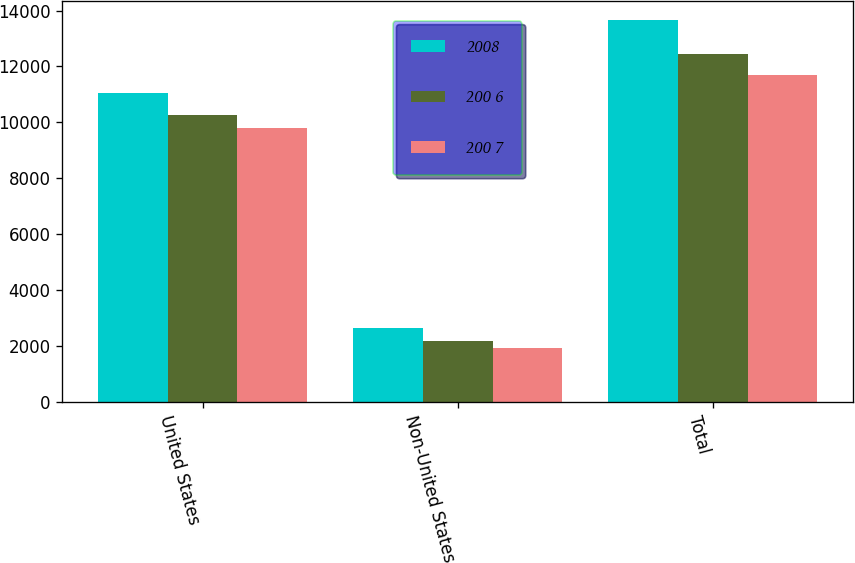Convert chart to OTSL. <chart><loc_0><loc_0><loc_500><loc_500><stacked_bar_chart><ecel><fcel>United States<fcel>Non-United States<fcel>Total<nl><fcel>2008<fcel>11036.7<fcel>2615.4<fcel>13652.1<nl><fcel>200 6<fcel>10258.7<fcel>2182.8<fcel>12441.5<nl><fcel>200 7<fcel>9810.6<fcel>1900.7<fcel>11711.3<nl></chart> 